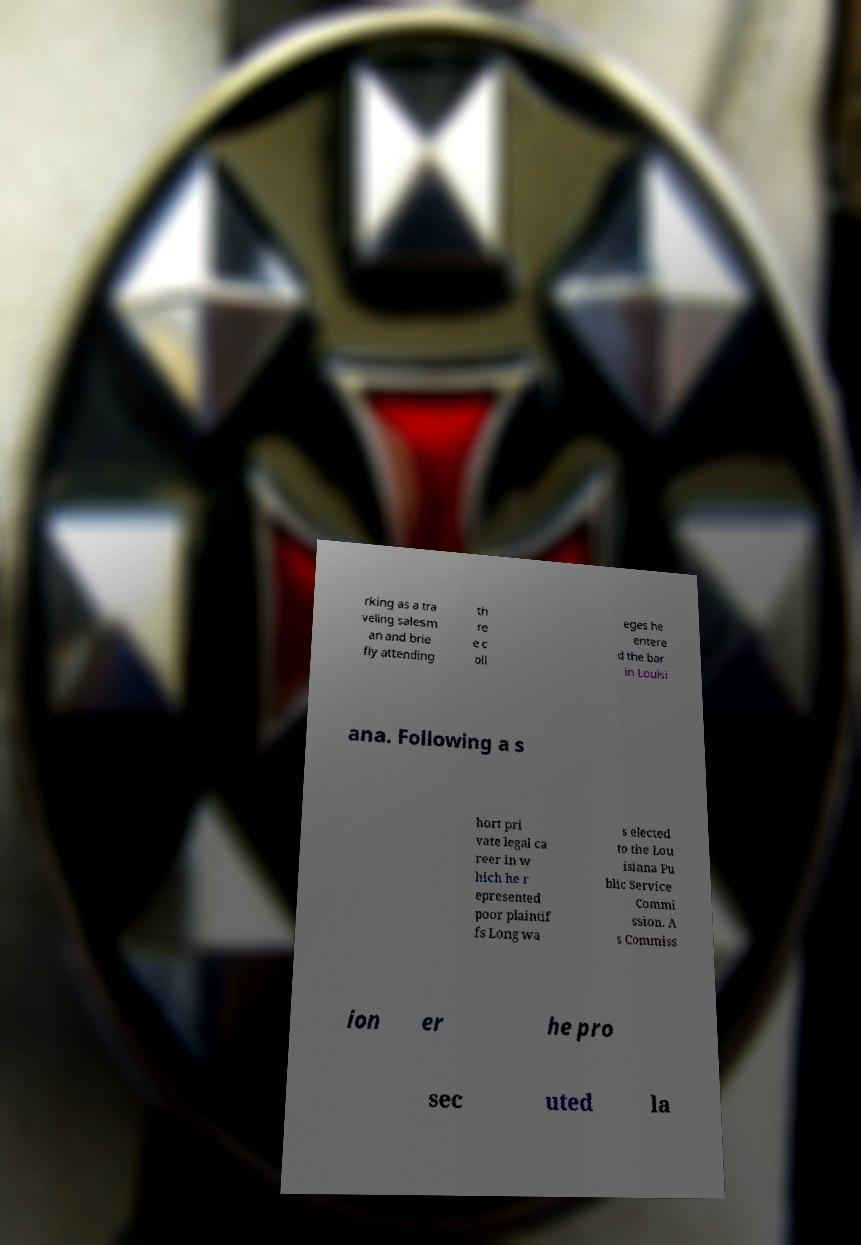I need the written content from this picture converted into text. Can you do that? rking as a tra veling salesm an and brie fly attending th re e c oll eges he entere d the bar in Louisi ana. Following a s hort pri vate legal ca reer in w hich he r epresented poor plaintif fs Long wa s elected to the Lou isiana Pu blic Service Commi ssion. A s Commiss ion er he pro sec uted la 